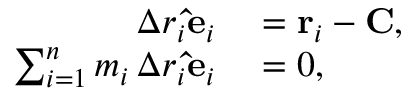Convert formula to latex. <formula><loc_0><loc_0><loc_500><loc_500>\begin{array} { r l } { \Delta r _ { i } \hat { e } _ { i } } & = r _ { i } - C , } \\ { \sum _ { i = 1 } ^ { n } m _ { i } \, \Delta r _ { i } \hat { e } _ { i } } & = 0 , } \end{array}</formula> 